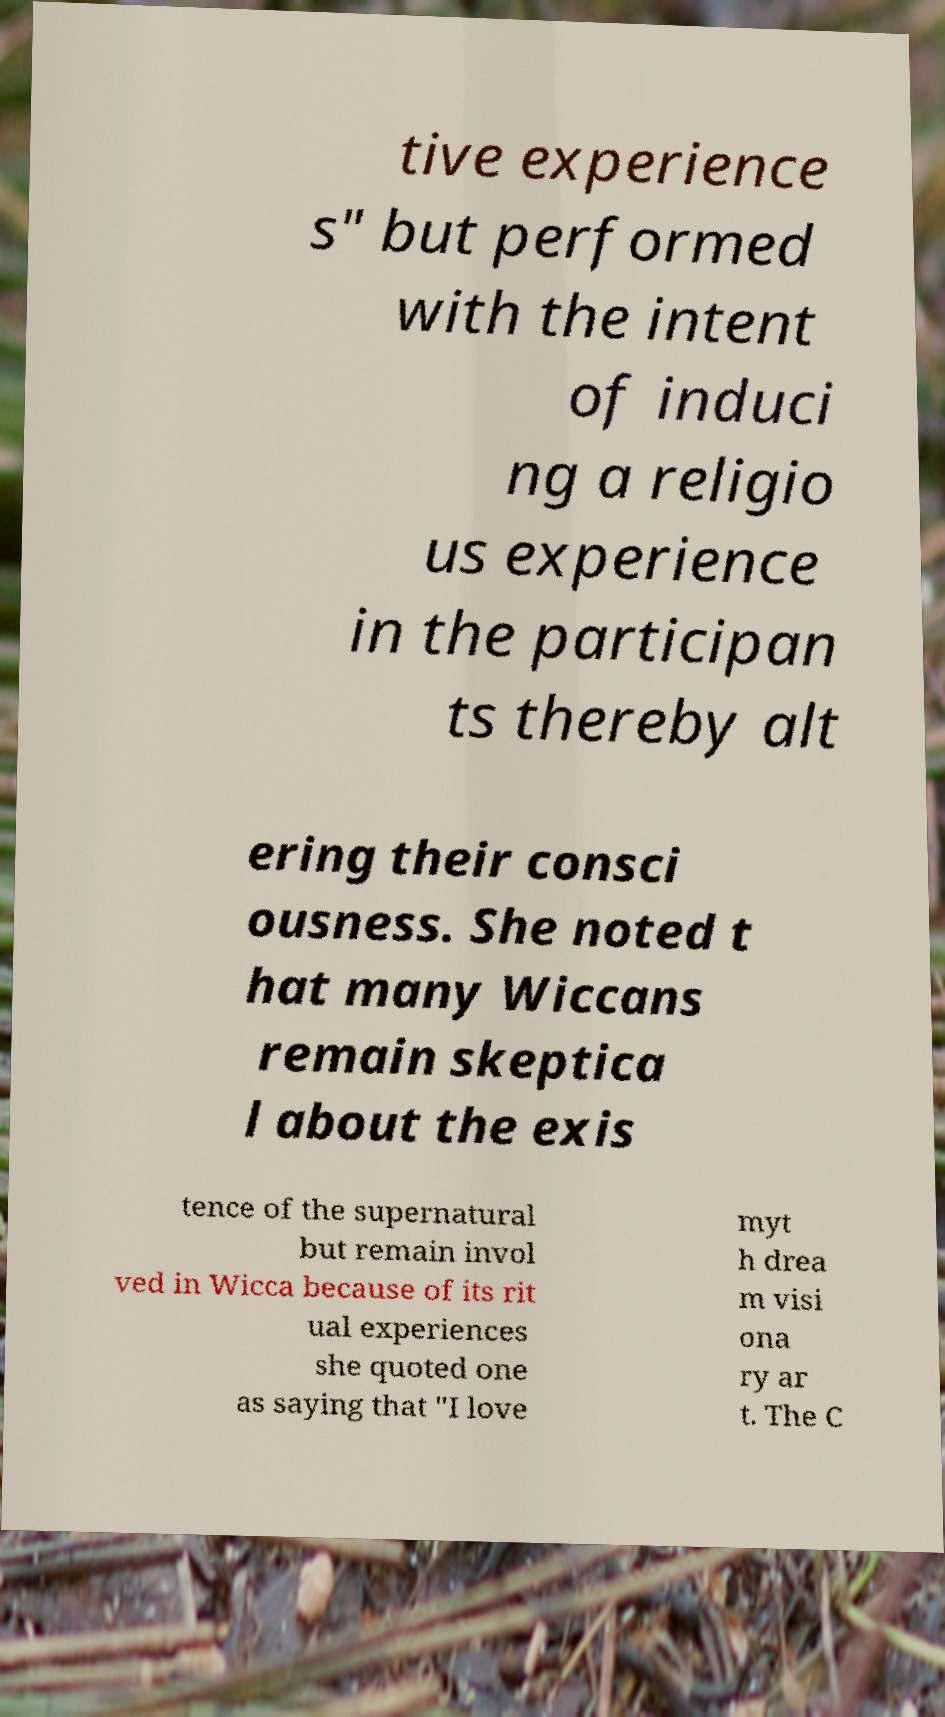Please read and relay the text visible in this image. What does it say? tive experience s" but performed with the intent of induci ng a religio us experience in the participan ts thereby alt ering their consci ousness. She noted t hat many Wiccans remain skeptica l about the exis tence of the supernatural but remain invol ved in Wicca because of its rit ual experiences she quoted one as saying that "I love myt h drea m visi ona ry ar t. The C 